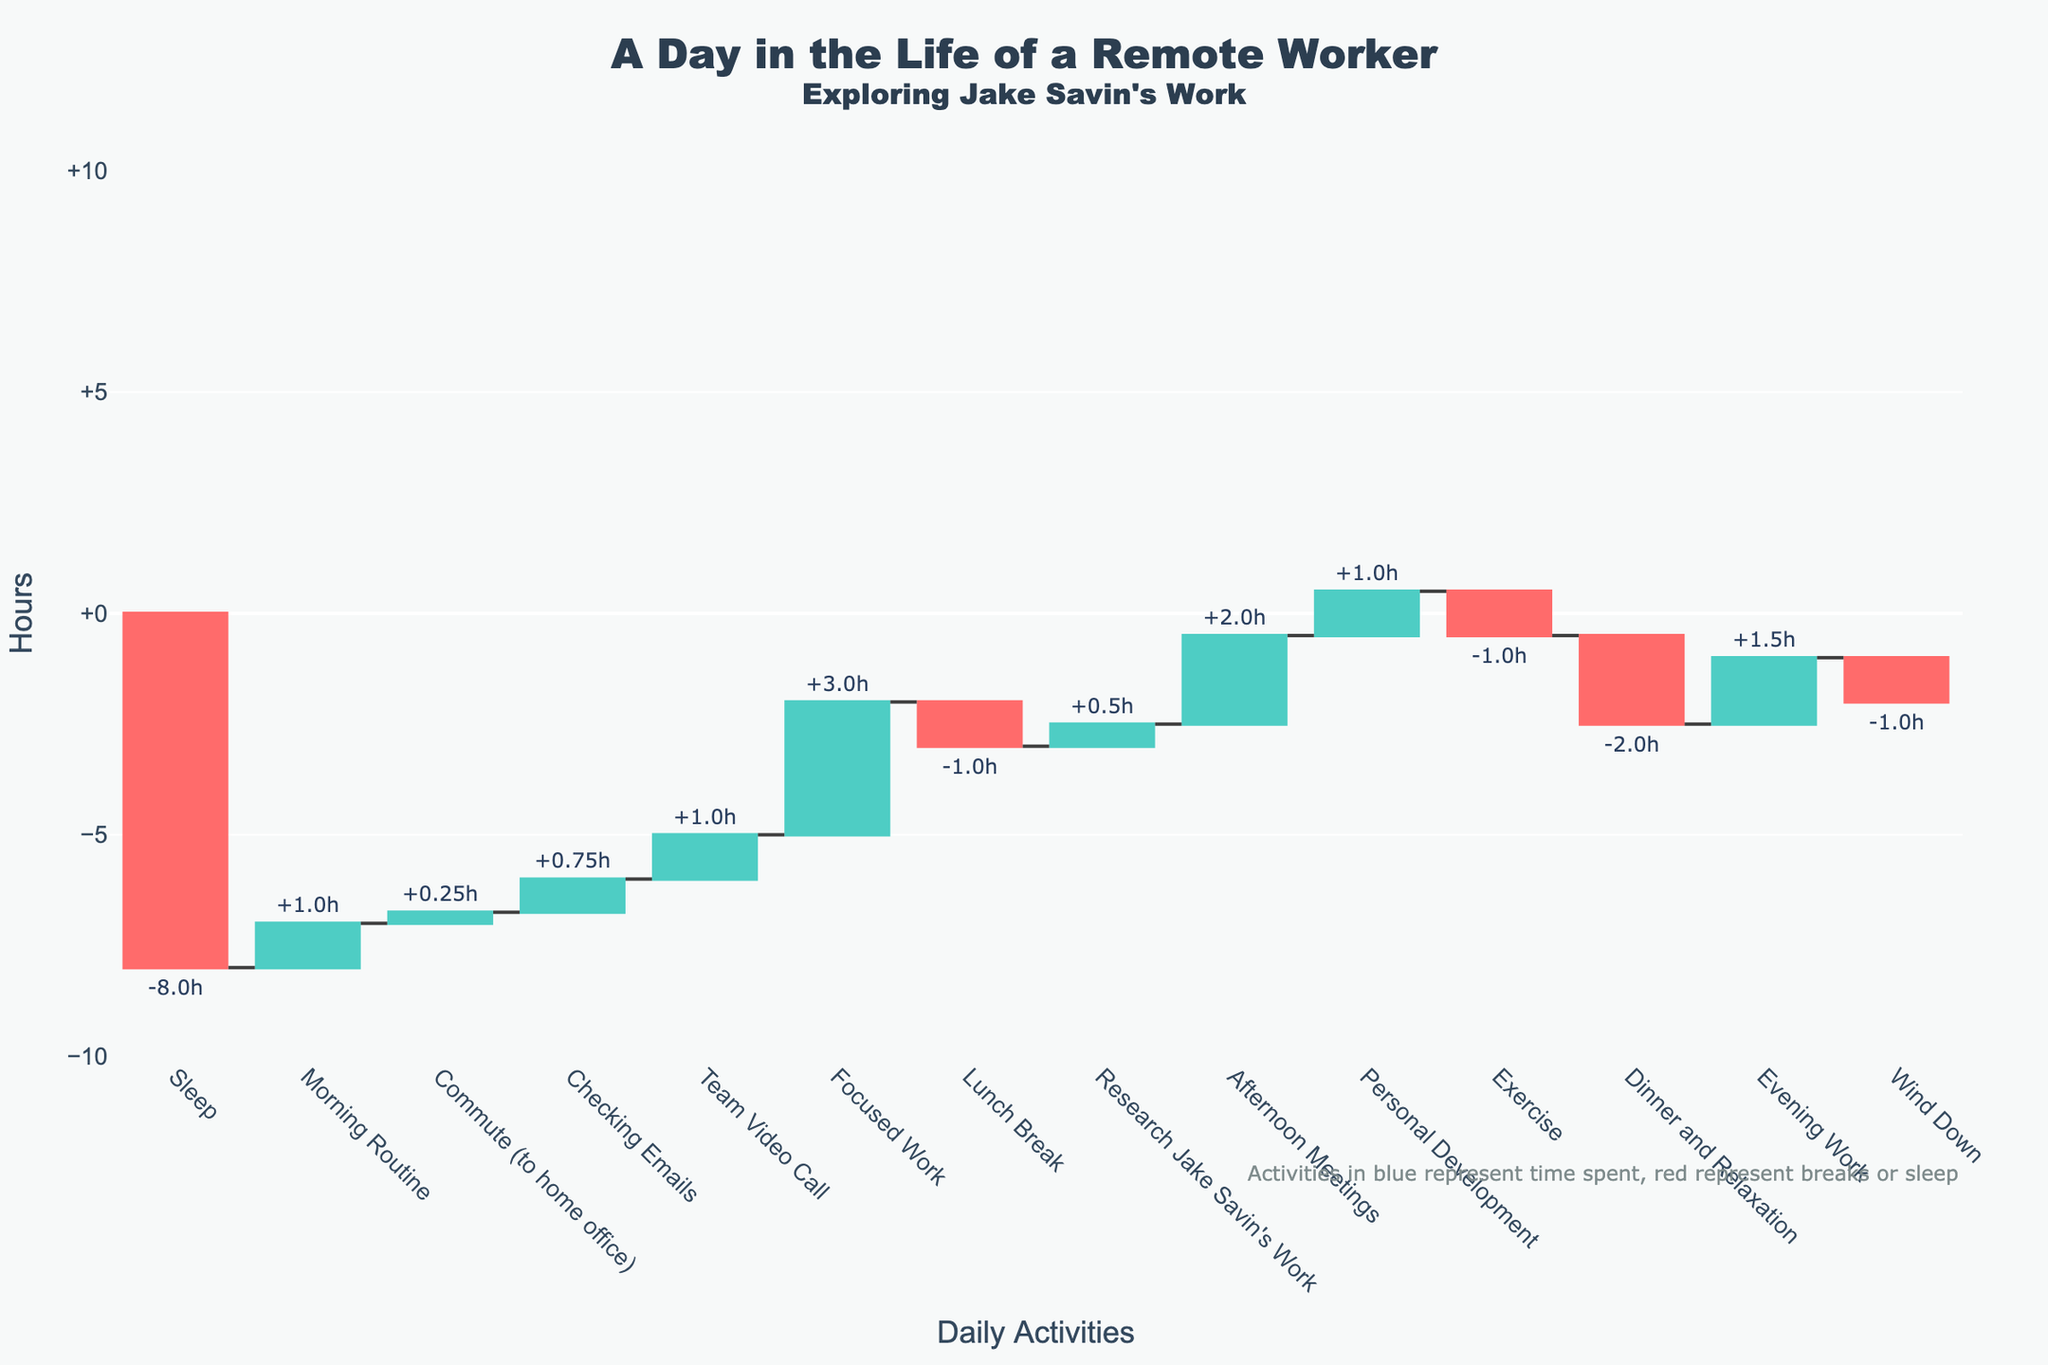What's the title of the figure? The title is usually displayed at the top of a chart. Here, the title is "A Day in the Life of a Remote Worker" with a subtitle "Exploring Jake Savin's Work".
Answer: A Day in the Life of a Remote Worker How many hours are spent sleeping? The time spent sleeping is indicated by the activity labeled "Sleep" with a value of -8 hours.
Answer: 8 hours Which activity consumes the most time in a single block? To find the activity that consumes the most time, we look at the length of bars. "Focused Work" has a value of 3 hours, which is the highest among all positive values.
Answer: Focused Work What is the net cumulative time after "Lunch Break"? To find the cumulative time after "Lunch Break", we can sum up the hours from the beginning to "Lunch Break". It's -8 (Sleep) + 1 (Morning Routine) + 0.25 (Commute) + 0.75 (Emails) + 1 (Video Call) + 3 (Focused Work) - 1 (Lunch Break) which equals -3.
Answer: -3 hours How much time is spent on activities related to Jake Savin's work? The time spent on "Research Jake Savin's Work" is specifically listed as 0.5 hours.
Answer: 0.5 hours Which activity immediately follows "Afternoon Meetings" and how much time is spent on it? By looking at the sequence of activities, "Personal Development" follows "Afternoon Meetings" and it has 1 hour assigned to it.
Answer: Personal Development, 1 hour How many activities are considered breaks or rest time? Activities like sleep, lunch break, exercise, dinner and relaxation, and wind down can be considered rest times. This totals five activities.
Answer: 5 activities What is the total time spent on work-related activities? Add the hours of work-related activities: Checking Emails (0.75) + Team Video Call (1) + Focused Work (3) + Research Jake Savin's Work (0.5) + Afternoon Meetings (2) + Evening Work (1.5) which equals 8.75 hours.
Answer: 8.75 hours Which activities have negative values and what do they represent? The activities with negative values are "Sleep" (-8), "Lunch Break" (-1), "Exercise" (-1), "Dinner and Relaxation" (-2), "Wind Down" (-1). They represent breaks or rest periods.
Answer: Sleep, Lunch Break, Exercise, Dinner and Relaxation, Wind Down Compare the time spent on "Exercise" and "Evening Work". "Exercise" has -1 hour and "Evening Work" has 1.5 hours. Therefore, more time is spent on "Evening Work" than "Exercise".
Answer: Evening Work > Exercise 